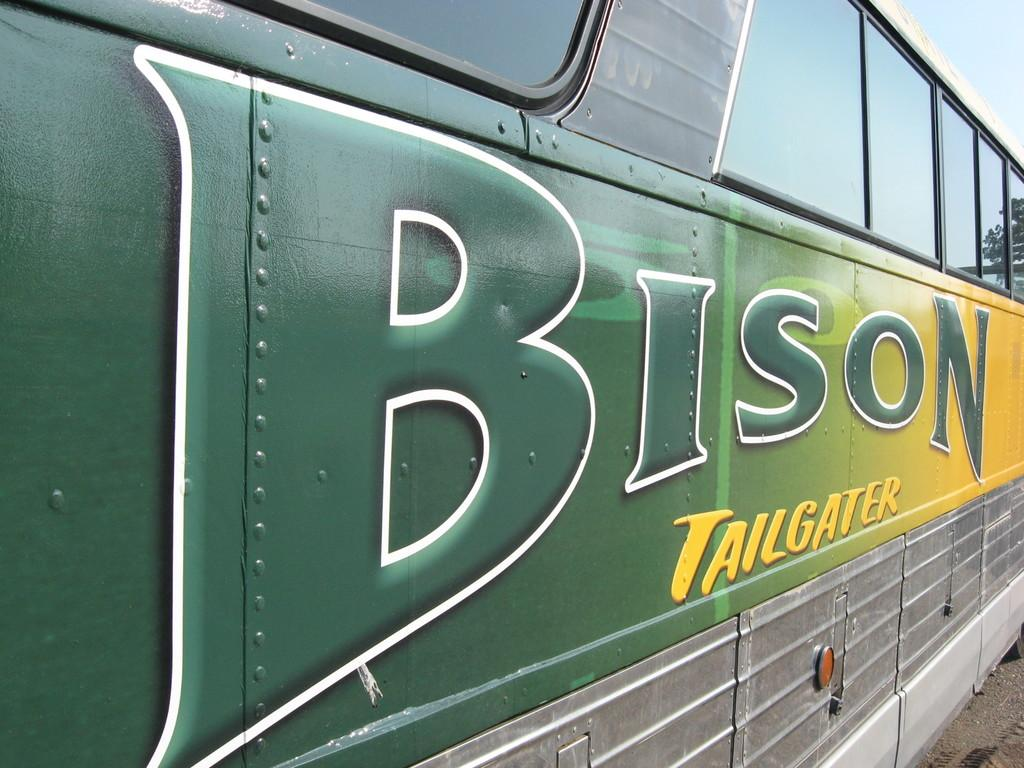<image>
Write a terse but informative summary of the picture. a bus that has the word Bison on the side 